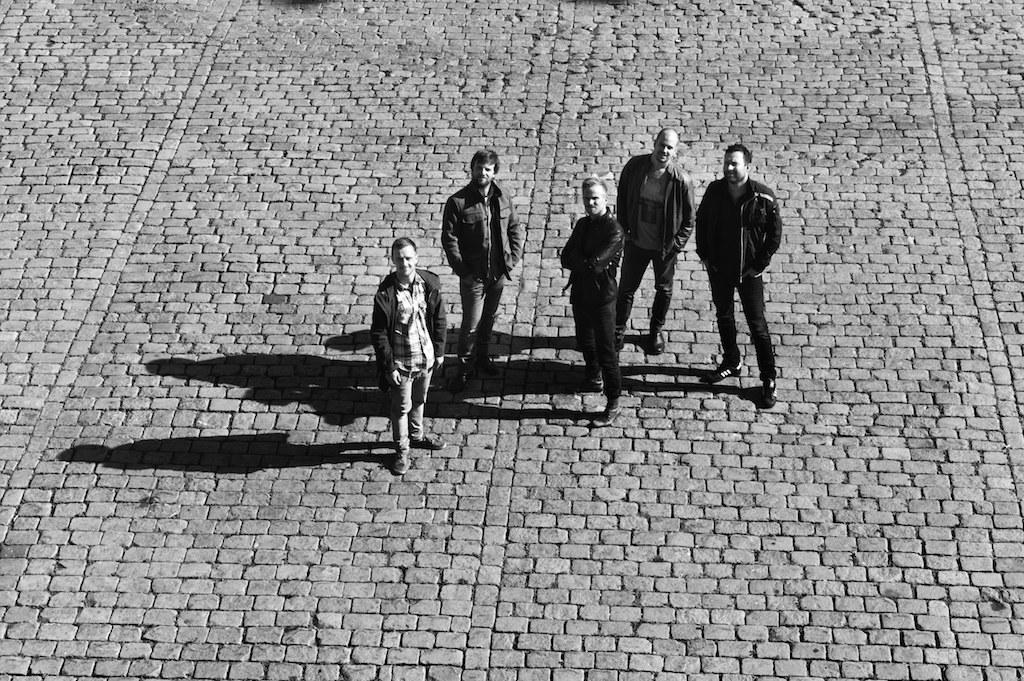How many people are in the image? There is a group of people in the image, but the exact number is not specified. What can be seen on the ground in the image? There are shadows on the ground in the image. What type of boat is floating in the water in the image? There is no boat or water present in the image; it only features a group of people and shadows on the ground. 